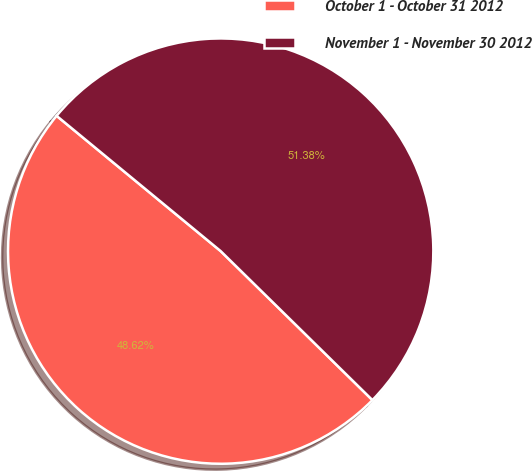Convert chart. <chart><loc_0><loc_0><loc_500><loc_500><pie_chart><fcel>October 1 - October 31 2012<fcel>November 1 - November 30 2012<nl><fcel>48.62%<fcel>51.38%<nl></chart> 